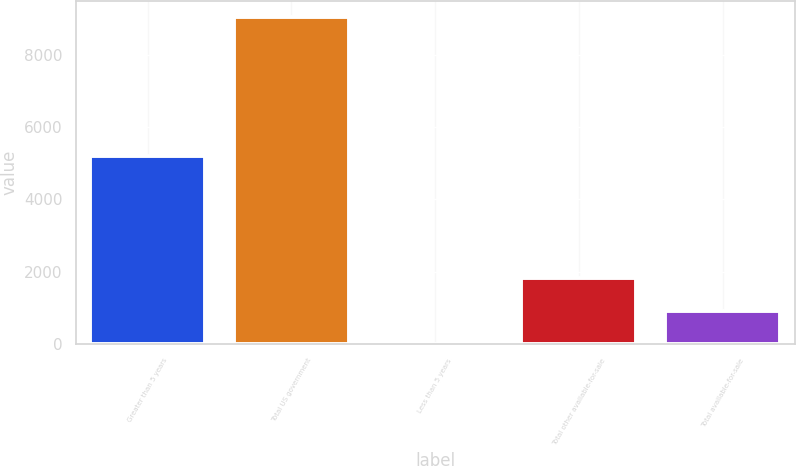Convert chart. <chart><loc_0><loc_0><loc_500><loc_500><bar_chart><fcel>Greater than 5 years<fcel>Total US government<fcel>Less than 5 years<fcel>Total other available-for-sale<fcel>Total available-for-sale<nl><fcel>5207<fcel>9041<fcel>19<fcel>1823.4<fcel>921.2<nl></chart> 